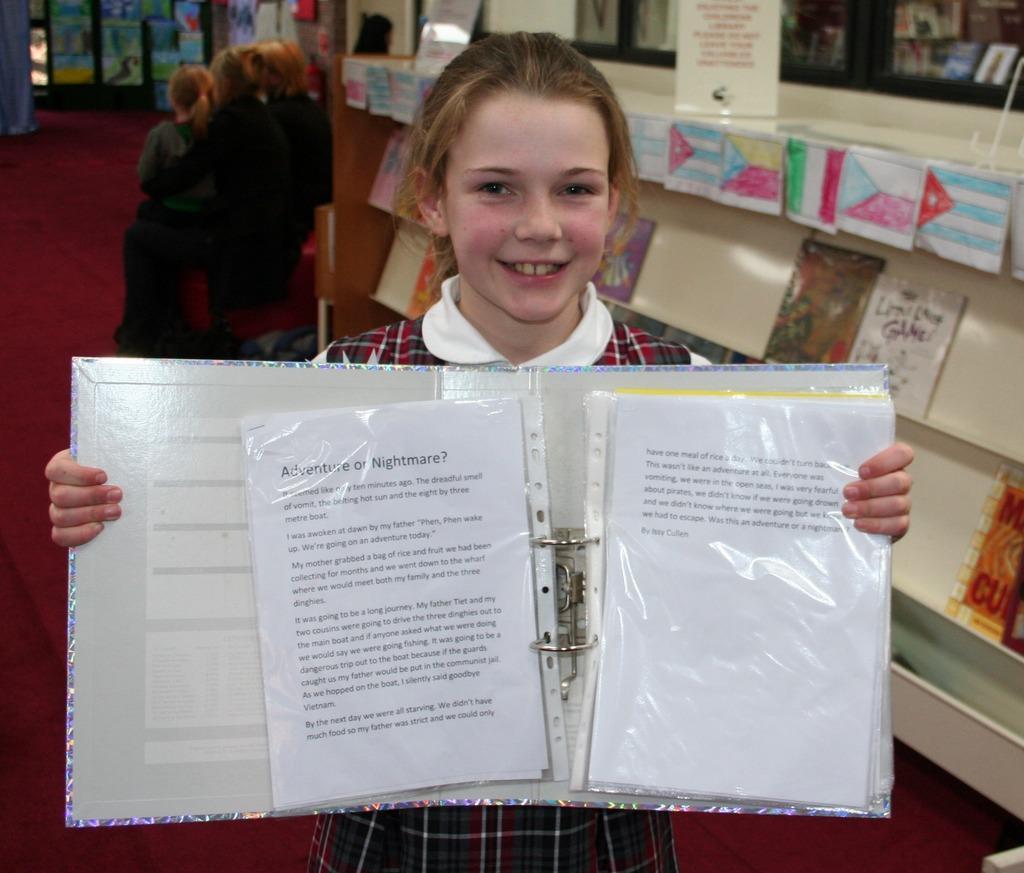In one or two sentences, can you explain what this image depicts? In this image, there are a few people. Among them, we can see a girl is holding an object and standing. We can see some wood on the right with some objects. We can also see the ground. There are a few posts with images and text. 